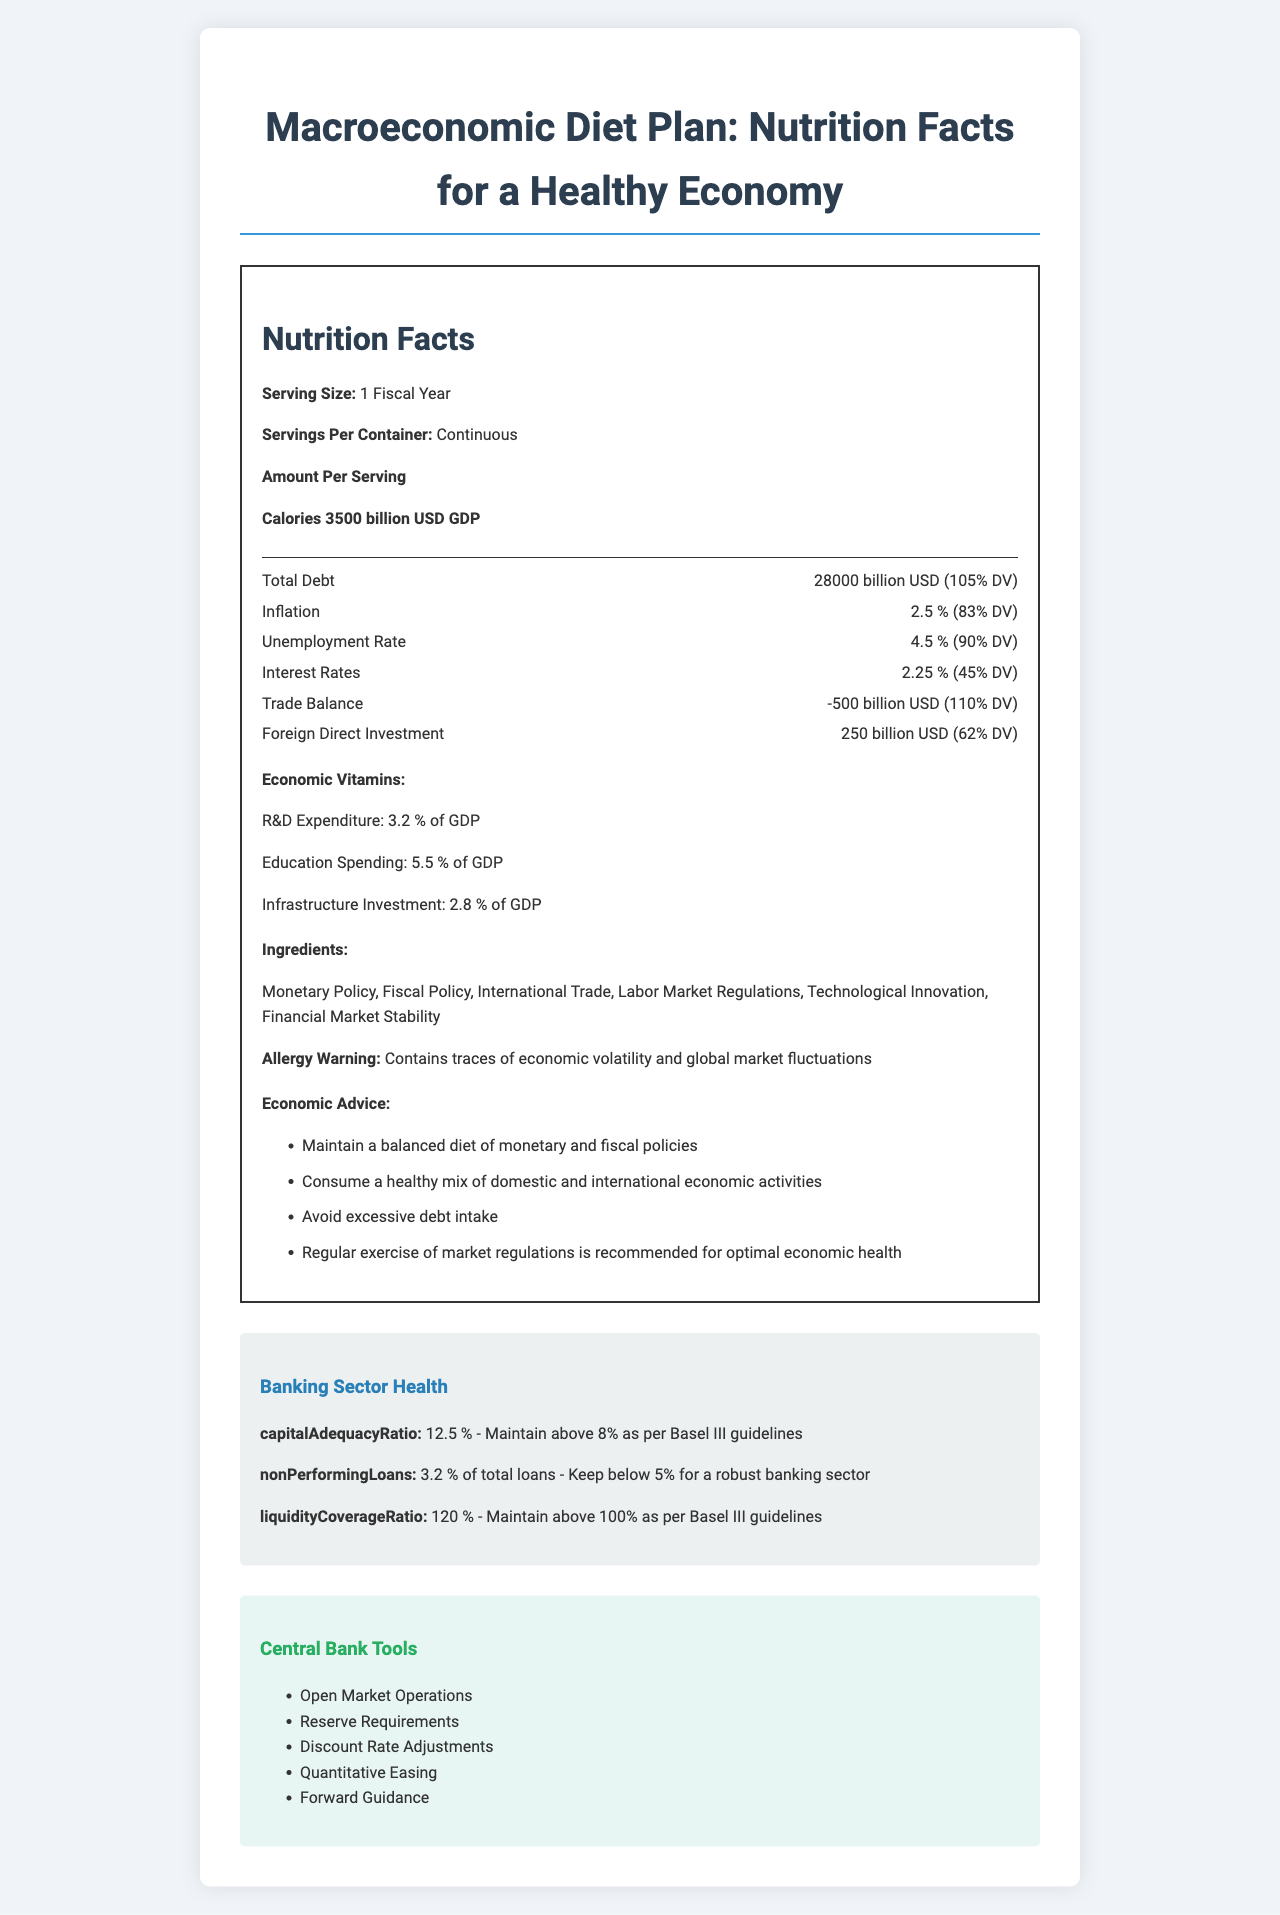What is the serving size of the macroeconomic diet plan? The document states that the serving size is "1 Fiscal Year."
Answer: 1 Fiscal Year How many calories are there per serving in the macroeconomic diet plan? The document specifies that 1 Fiscal Year contains 3500 billion USD GDP as the calorie content.
Answer: 3500 billion USD GDP What is the Daily Value percentage for Total Debt? The document lists the Daily Value percentage for Total Debt as 105%.
Answer: 105% Which economic nutrient has a negative value? A. Total Debt B. Inflation C. Trade Balance D. Foreign Direct Investment The Trade Balance is listed with a value of -500 billion USD, which is negative.
Answer: C. Trade Balance What is the recommended level of the Liquidity Coverage Ratio for a healthy banking sector? The document states that the Liquidity Coverage Ratio should be maintained above 100% according to Basel III guidelines.
Answer: Maintain above 100% as per Basel III guidelines What are some of the main ingredients in the macroeconomic diet plan? The ingredients section of the document lists these items as key components of the macroeconomic diet plan.
Answer: Monetary Policy, Fiscal Policy, International Trade, Labor Market Regulations, Technological Innovation, Financial Market Stability True or False: The document suggests avoiding excessive debt intake. One of the pieces of advice in the document is to "Avoid excessive debt intake."
Answer: True What is the main idea of this document? The document details various economic metrics as if they were nutritional components, providing guidance on maintaining a prosperous and stable economy.
Answer: The document is a metaphorical Nutrition Facts Label for a healthy economy, listing key economic "nutrients," advice for maintaining economic stability, and health metrics for the banking sector. What is the percentage of daily value for the Unemployment Rate? The document states that the Unemployment Rate is 4.5% with a daily value percentage of 90%.
Answer: 90% Which of the following is not listed as a central bank tool in the document? A. Open Market Operations B. Capital Controls C. Reserve Requirements D. Forward Guidance The central bank tools listed are Open Market Operations, Reserve Requirements, Discount Rate Adjustments, Quantitative Easing, and Forward Guidance. Capital Controls is not mentioned.
Answer: B. Capital Controls According to the document, which nutrient has the highest daily value percentage? The Trade Balance has a daily value percentage of 110%, which is the highest listed in the document.
Answer: Trade Balance How much of GDP is recommended to be spent on R&D Expenditure? The document lists R&D Expenditure as 3.2% of GDP.
Answer: 3.2% of GDP Which banking sector health metric indicates a recommendation to maintain a value above 8%? The Capital Adequacy Ratio recommendation is to maintain above 8% as per Basel III guidelines.
Answer: Capital Adequacy Ratio What is the daily value percentage of Interest Rates? The daily value percentage for Interest Rates is listed as 45%.
Answer: 45% Does the document provide information on the specific allocation of infrastructure investment funds? The document lists Infrastructure Investment as 2.8% of GDP but does not detail the specific allocation of these funds.
Answer: Not enough information 